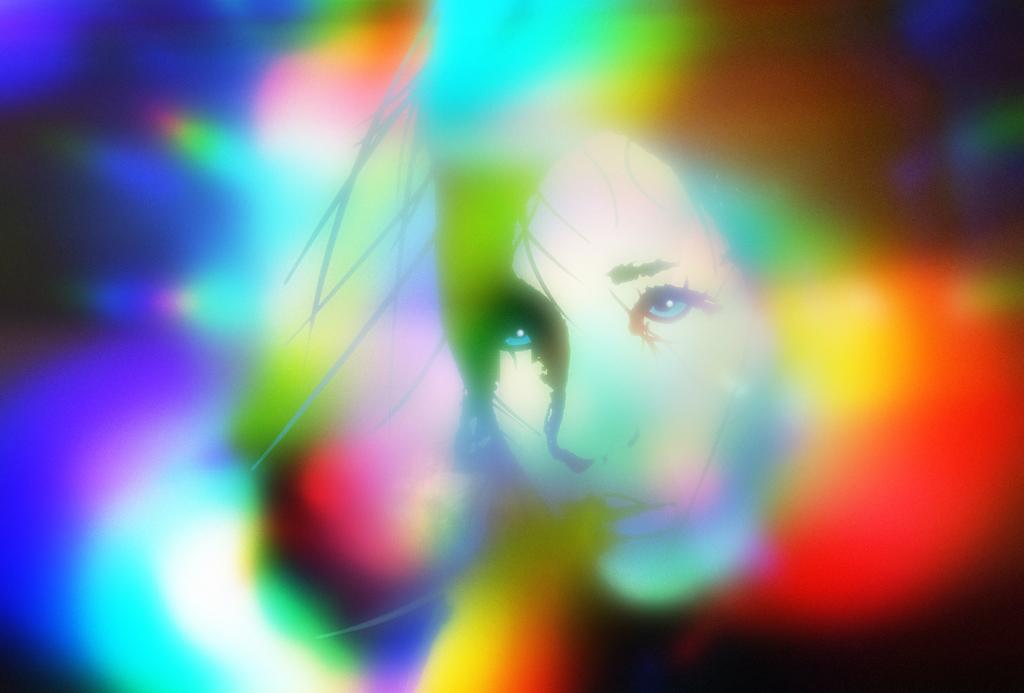What is the main subject of the image? The main subject of the image is a woman's face. What can be seen in terms of lighting in the image? There are different colors of lights in the image. What type of toy is the woman folding in the image? There is no toy present in the image, and the woman is not folding anything. 